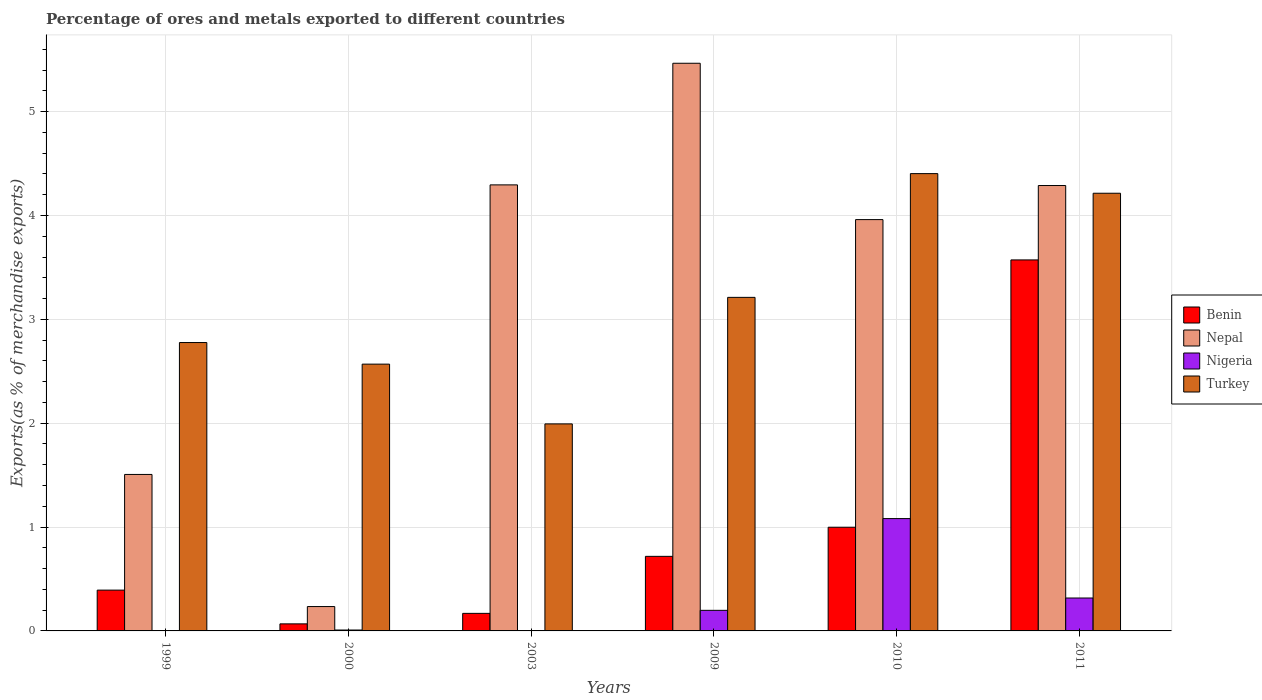How many groups of bars are there?
Keep it short and to the point. 6. How many bars are there on the 5th tick from the left?
Offer a terse response. 4. How many bars are there on the 1st tick from the right?
Ensure brevity in your answer.  4. What is the label of the 6th group of bars from the left?
Ensure brevity in your answer.  2011. In how many cases, is the number of bars for a given year not equal to the number of legend labels?
Keep it short and to the point. 0. What is the percentage of exports to different countries in Benin in 2000?
Offer a terse response. 0.07. Across all years, what is the maximum percentage of exports to different countries in Nepal?
Offer a very short reply. 5.47. Across all years, what is the minimum percentage of exports to different countries in Turkey?
Your response must be concise. 1.99. In which year was the percentage of exports to different countries in Nepal maximum?
Provide a succinct answer. 2009. In which year was the percentage of exports to different countries in Benin minimum?
Keep it short and to the point. 2000. What is the total percentage of exports to different countries in Benin in the graph?
Your response must be concise. 5.92. What is the difference between the percentage of exports to different countries in Turkey in 2009 and that in 2011?
Provide a succinct answer. -1. What is the difference between the percentage of exports to different countries in Nigeria in 2009 and the percentage of exports to different countries in Benin in 1999?
Offer a terse response. -0.19. What is the average percentage of exports to different countries in Nepal per year?
Ensure brevity in your answer.  3.29. In the year 2003, what is the difference between the percentage of exports to different countries in Nigeria and percentage of exports to different countries in Benin?
Your answer should be compact. -0.17. In how many years, is the percentage of exports to different countries in Benin greater than 3.8 %?
Give a very brief answer. 0. What is the ratio of the percentage of exports to different countries in Benin in 2000 to that in 2011?
Provide a short and direct response. 0.02. Is the percentage of exports to different countries in Benin in 2009 less than that in 2011?
Offer a very short reply. Yes. What is the difference between the highest and the second highest percentage of exports to different countries in Nigeria?
Provide a succinct answer. 0.76. What is the difference between the highest and the lowest percentage of exports to different countries in Nepal?
Offer a very short reply. 5.23. In how many years, is the percentage of exports to different countries in Nepal greater than the average percentage of exports to different countries in Nepal taken over all years?
Make the answer very short. 4. Is the sum of the percentage of exports to different countries in Nepal in 2003 and 2011 greater than the maximum percentage of exports to different countries in Turkey across all years?
Give a very brief answer. Yes. Is it the case that in every year, the sum of the percentage of exports to different countries in Nepal and percentage of exports to different countries in Nigeria is greater than the sum of percentage of exports to different countries in Turkey and percentage of exports to different countries in Benin?
Offer a very short reply. No. Is it the case that in every year, the sum of the percentage of exports to different countries in Turkey and percentage of exports to different countries in Nepal is greater than the percentage of exports to different countries in Nigeria?
Give a very brief answer. Yes. How many bars are there?
Your answer should be compact. 24. How many years are there in the graph?
Provide a short and direct response. 6. Are the values on the major ticks of Y-axis written in scientific E-notation?
Offer a very short reply. No. Where does the legend appear in the graph?
Keep it short and to the point. Center right. How many legend labels are there?
Offer a very short reply. 4. How are the legend labels stacked?
Offer a terse response. Vertical. What is the title of the graph?
Provide a short and direct response. Percentage of ores and metals exported to different countries. Does "Croatia" appear as one of the legend labels in the graph?
Offer a terse response. No. What is the label or title of the Y-axis?
Give a very brief answer. Exports(as % of merchandise exports). What is the Exports(as % of merchandise exports) of Benin in 1999?
Your answer should be compact. 0.39. What is the Exports(as % of merchandise exports) of Nepal in 1999?
Give a very brief answer. 1.51. What is the Exports(as % of merchandise exports) of Nigeria in 1999?
Your answer should be very brief. 0. What is the Exports(as % of merchandise exports) in Turkey in 1999?
Your response must be concise. 2.78. What is the Exports(as % of merchandise exports) in Benin in 2000?
Make the answer very short. 0.07. What is the Exports(as % of merchandise exports) in Nepal in 2000?
Your answer should be compact. 0.23. What is the Exports(as % of merchandise exports) in Nigeria in 2000?
Provide a short and direct response. 0.01. What is the Exports(as % of merchandise exports) in Turkey in 2000?
Make the answer very short. 2.57. What is the Exports(as % of merchandise exports) of Benin in 2003?
Provide a succinct answer. 0.17. What is the Exports(as % of merchandise exports) of Nepal in 2003?
Your answer should be compact. 4.29. What is the Exports(as % of merchandise exports) of Nigeria in 2003?
Your response must be concise. 0. What is the Exports(as % of merchandise exports) in Turkey in 2003?
Give a very brief answer. 1.99. What is the Exports(as % of merchandise exports) in Benin in 2009?
Give a very brief answer. 0.72. What is the Exports(as % of merchandise exports) of Nepal in 2009?
Your response must be concise. 5.47. What is the Exports(as % of merchandise exports) of Nigeria in 2009?
Your response must be concise. 0.2. What is the Exports(as % of merchandise exports) of Turkey in 2009?
Your answer should be very brief. 3.21. What is the Exports(as % of merchandise exports) of Benin in 2010?
Give a very brief answer. 1. What is the Exports(as % of merchandise exports) in Nepal in 2010?
Your answer should be compact. 3.96. What is the Exports(as % of merchandise exports) in Nigeria in 2010?
Your response must be concise. 1.08. What is the Exports(as % of merchandise exports) of Turkey in 2010?
Offer a terse response. 4.4. What is the Exports(as % of merchandise exports) in Benin in 2011?
Provide a short and direct response. 3.57. What is the Exports(as % of merchandise exports) of Nepal in 2011?
Your response must be concise. 4.29. What is the Exports(as % of merchandise exports) of Nigeria in 2011?
Ensure brevity in your answer.  0.32. What is the Exports(as % of merchandise exports) in Turkey in 2011?
Offer a very short reply. 4.21. Across all years, what is the maximum Exports(as % of merchandise exports) in Benin?
Keep it short and to the point. 3.57. Across all years, what is the maximum Exports(as % of merchandise exports) of Nepal?
Your answer should be compact. 5.47. Across all years, what is the maximum Exports(as % of merchandise exports) of Nigeria?
Give a very brief answer. 1.08. Across all years, what is the maximum Exports(as % of merchandise exports) in Turkey?
Provide a short and direct response. 4.4. Across all years, what is the minimum Exports(as % of merchandise exports) in Benin?
Your answer should be compact. 0.07. Across all years, what is the minimum Exports(as % of merchandise exports) in Nepal?
Your answer should be compact. 0.23. Across all years, what is the minimum Exports(as % of merchandise exports) of Nigeria?
Provide a short and direct response. 0. Across all years, what is the minimum Exports(as % of merchandise exports) of Turkey?
Offer a very short reply. 1.99. What is the total Exports(as % of merchandise exports) of Benin in the graph?
Ensure brevity in your answer.  5.92. What is the total Exports(as % of merchandise exports) of Nepal in the graph?
Ensure brevity in your answer.  19.75. What is the total Exports(as % of merchandise exports) of Nigeria in the graph?
Your response must be concise. 1.61. What is the total Exports(as % of merchandise exports) in Turkey in the graph?
Give a very brief answer. 19.17. What is the difference between the Exports(as % of merchandise exports) in Benin in 1999 and that in 2000?
Your response must be concise. 0.32. What is the difference between the Exports(as % of merchandise exports) in Nepal in 1999 and that in 2000?
Your answer should be compact. 1.27. What is the difference between the Exports(as % of merchandise exports) of Nigeria in 1999 and that in 2000?
Offer a very short reply. -0.01. What is the difference between the Exports(as % of merchandise exports) of Turkey in 1999 and that in 2000?
Your answer should be compact. 0.21. What is the difference between the Exports(as % of merchandise exports) of Benin in 1999 and that in 2003?
Make the answer very short. 0.22. What is the difference between the Exports(as % of merchandise exports) in Nepal in 1999 and that in 2003?
Offer a very short reply. -2.79. What is the difference between the Exports(as % of merchandise exports) of Nigeria in 1999 and that in 2003?
Provide a short and direct response. -0. What is the difference between the Exports(as % of merchandise exports) in Turkey in 1999 and that in 2003?
Provide a short and direct response. 0.78. What is the difference between the Exports(as % of merchandise exports) in Benin in 1999 and that in 2009?
Keep it short and to the point. -0.33. What is the difference between the Exports(as % of merchandise exports) in Nepal in 1999 and that in 2009?
Your answer should be compact. -3.96. What is the difference between the Exports(as % of merchandise exports) in Nigeria in 1999 and that in 2009?
Your response must be concise. -0.2. What is the difference between the Exports(as % of merchandise exports) of Turkey in 1999 and that in 2009?
Ensure brevity in your answer.  -0.43. What is the difference between the Exports(as % of merchandise exports) in Benin in 1999 and that in 2010?
Offer a terse response. -0.61. What is the difference between the Exports(as % of merchandise exports) in Nepal in 1999 and that in 2010?
Your answer should be compact. -2.45. What is the difference between the Exports(as % of merchandise exports) in Nigeria in 1999 and that in 2010?
Your answer should be very brief. -1.08. What is the difference between the Exports(as % of merchandise exports) in Turkey in 1999 and that in 2010?
Ensure brevity in your answer.  -1.63. What is the difference between the Exports(as % of merchandise exports) of Benin in 1999 and that in 2011?
Make the answer very short. -3.18. What is the difference between the Exports(as % of merchandise exports) in Nepal in 1999 and that in 2011?
Your response must be concise. -2.78. What is the difference between the Exports(as % of merchandise exports) of Nigeria in 1999 and that in 2011?
Provide a short and direct response. -0.31. What is the difference between the Exports(as % of merchandise exports) in Turkey in 1999 and that in 2011?
Ensure brevity in your answer.  -1.44. What is the difference between the Exports(as % of merchandise exports) in Benin in 2000 and that in 2003?
Offer a very short reply. -0.1. What is the difference between the Exports(as % of merchandise exports) of Nepal in 2000 and that in 2003?
Keep it short and to the point. -4.06. What is the difference between the Exports(as % of merchandise exports) in Nigeria in 2000 and that in 2003?
Your answer should be compact. 0.01. What is the difference between the Exports(as % of merchandise exports) of Turkey in 2000 and that in 2003?
Give a very brief answer. 0.58. What is the difference between the Exports(as % of merchandise exports) in Benin in 2000 and that in 2009?
Offer a very short reply. -0.65. What is the difference between the Exports(as % of merchandise exports) of Nepal in 2000 and that in 2009?
Your response must be concise. -5.23. What is the difference between the Exports(as % of merchandise exports) in Nigeria in 2000 and that in 2009?
Your response must be concise. -0.19. What is the difference between the Exports(as % of merchandise exports) of Turkey in 2000 and that in 2009?
Ensure brevity in your answer.  -0.64. What is the difference between the Exports(as % of merchandise exports) in Benin in 2000 and that in 2010?
Ensure brevity in your answer.  -0.93. What is the difference between the Exports(as % of merchandise exports) in Nepal in 2000 and that in 2010?
Provide a succinct answer. -3.73. What is the difference between the Exports(as % of merchandise exports) of Nigeria in 2000 and that in 2010?
Ensure brevity in your answer.  -1.07. What is the difference between the Exports(as % of merchandise exports) of Turkey in 2000 and that in 2010?
Give a very brief answer. -1.83. What is the difference between the Exports(as % of merchandise exports) in Benin in 2000 and that in 2011?
Offer a terse response. -3.5. What is the difference between the Exports(as % of merchandise exports) of Nepal in 2000 and that in 2011?
Your answer should be compact. -4.05. What is the difference between the Exports(as % of merchandise exports) of Nigeria in 2000 and that in 2011?
Offer a terse response. -0.31. What is the difference between the Exports(as % of merchandise exports) of Turkey in 2000 and that in 2011?
Your response must be concise. -1.65. What is the difference between the Exports(as % of merchandise exports) of Benin in 2003 and that in 2009?
Keep it short and to the point. -0.55. What is the difference between the Exports(as % of merchandise exports) of Nepal in 2003 and that in 2009?
Provide a succinct answer. -1.17. What is the difference between the Exports(as % of merchandise exports) of Nigeria in 2003 and that in 2009?
Keep it short and to the point. -0.2. What is the difference between the Exports(as % of merchandise exports) of Turkey in 2003 and that in 2009?
Your answer should be very brief. -1.22. What is the difference between the Exports(as % of merchandise exports) in Benin in 2003 and that in 2010?
Make the answer very short. -0.83. What is the difference between the Exports(as % of merchandise exports) of Nepal in 2003 and that in 2010?
Offer a very short reply. 0.33. What is the difference between the Exports(as % of merchandise exports) of Nigeria in 2003 and that in 2010?
Provide a succinct answer. -1.08. What is the difference between the Exports(as % of merchandise exports) of Turkey in 2003 and that in 2010?
Offer a very short reply. -2.41. What is the difference between the Exports(as % of merchandise exports) in Benin in 2003 and that in 2011?
Give a very brief answer. -3.4. What is the difference between the Exports(as % of merchandise exports) of Nepal in 2003 and that in 2011?
Keep it short and to the point. 0.01. What is the difference between the Exports(as % of merchandise exports) of Nigeria in 2003 and that in 2011?
Offer a very short reply. -0.31. What is the difference between the Exports(as % of merchandise exports) in Turkey in 2003 and that in 2011?
Your answer should be very brief. -2.22. What is the difference between the Exports(as % of merchandise exports) of Benin in 2009 and that in 2010?
Make the answer very short. -0.28. What is the difference between the Exports(as % of merchandise exports) in Nepal in 2009 and that in 2010?
Your response must be concise. 1.51. What is the difference between the Exports(as % of merchandise exports) in Nigeria in 2009 and that in 2010?
Provide a short and direct response. -0.88. What is the difference between the Exports(as % of merchandise exports) in Turkey in 2009 and that in 2010?
Your answer should be very brief. -1.19. What is the difference between the Exports(as % of merchandise exports) in Benin in 2009 and that in 2011?
Provide a succinct answer. -2.85. What is the difference between the Exports(as % of merchandise exports) of Nepal in 2009 and that in 2011?
Your answer should be compact. 1.18. What is the difference between the Exports(as % of merchandise exports) of Nigeria in 2009 and that in 2011?
Ensure brevity in your answer.  -0.12. What is the difference between the Exports(as % of merchandise exports) in Turkey in 2009 and that in 2011?
Provide a short and direct response. -1. What is the difference between the Exports(as % of merchandise exports) in Benin in 2010 and that in 2011?
Ensure brevity in your answer.  -2.57. What is the difference between the Exports(as % of merchandise exports) of Nepal in 2010 and that in 2011?
Give a very brief answer. -0.33. What is the difference between the Exports(as % of merchandise exports) of Nigeria in 2010 and that in 2011?
Make the answer very short. 0.76. What is the difference between the Exports(as % of merchandise exports) of Turkey in 2010 and that in 2011?
Give a very brief answer. 0.19. What is the difference between the Exports(as % of merchandise exports) of Benin in 1999 and the Exports(as % of merchandise exports) of Nepal in 2000?
Give a very brief answer. 0.16. What is the difference between the Exports(as % of merchandise exports) in Benin in 1999 and the Exports(as % of merchandise exports) in Nigeria in 2000?
Your response must be concise. 0.38. What is the difference between the Exports(as % of merchandise exports) of Benin in 1999 and the Exports(as % of merchandise exports) of Turkey in 2000?
Keep it short and to the point. -2.18. What is the difference between the Exports(as % of merchandise exports) of Nepal in 1999 and the Exports(as % of merchandise exports) of Nigeria in 2000?
Offer a terse response. 1.5. What is the difference between the Exports(as % of merchandise exports) in Nepal in 1999 and the Exports(as % of merchandise exports) in Turkey in 2000?
Provide a short and direct response. -1.06. What is the difference between the Exports(as % of merchandise exports) in Nigeria in 1999 and the Exports(as % of merchandise exports) in Turkey in 2000?
Give a very brief answer. -2.57. What is the difference between the Exports(as % of merchandise exports) of Benin in 1999 and the Exports(as % of merchandise exports) of Nepal in 2003?
Give a very brief answer. -3.9. What is the difference between the Exports(as % of merchandise exports) of Benin in 1999 and the Exports(as % of merchandise exports) of Nigeria in 2003?
Keep it short and to the point. 0.39. What is the difference between the Exports(as % of merchandise exports) in Benin in 1999 and the Exports(as % of merchandise exports) in Turkey in 2003?
Provide a succinct answer. -1.6. What is the difference between the Exports(as % of merchandise exports) in Nepal in 1999 and the Exports(as % of merchandise exports) in Nigeria in 2003?
Your answer should be compact. 1.5. What is the difference between the Exports(as % of merchandise exports) in Nepal in 1999 and the Exports(as % of merchandise exports) in Turkey in 2003?
Your answer should be compact. -0.49. What is the difference between the Exports(as % of merchandise exports) in Nigeria in 1999 and the Exports(as % of merchandise exports) in Turkey in 2003?
Provide a succinct answer. -1.99. What is the difference between the Exports(as % of merchandise exports) in Benin in 1999 and the Exports(as % of merchandise exports) in Nepal in 2009?
Your answer should be very brief. -5.07. What is the difference between the Exports(as % of merchandise exports) in Benin in 1999 and the Exports(as % of merchandise exports) in Nigeria in 2009?
Provide a succinct answer. 0.19. What is the difference between the Exports(as % of merchandise exports) of Benin in 1999 and the Exports(as % of merchandise exports) of Turkey in 2009?
Provide a succinct answer. -2.82. What is the difference between the Exports(as % of merchandise exports) of Nepal in 1999 and the Exports(as % of merchandise exports) of Nigeria in 2009?
Make the answer very short. 1.31. What is the difference between the Exports(as % of merchandise exports) in Nepal in 1999 and the Exports(as % of merchandise exports) in Turkey in 2009?
Give a very brief answer. -1.7. What is the difference between the Exports(as % of merchandise exports) of Nigeria in 1999 and the Exports(as % of merchandise exports) of Turkey in 2009?
Your response must be concise. -3.21. What is the difference between the Exports(as % of merchandise exports) in Benin in 1999 and the Exports(as % of merchandise exports) in Nepal in 2010?
Give a very brief answer. -3.57. What is the difference between the Exports(as % of merchandise exports) of Benin in 1999 and the Exports(as % of merchandise exports) of Nigeria in 2010?
Your response must be concise. -0.69. What is the difference between the Exports(as % of merchandise exports) in Benin in 1999 and the Exports(as % of merchandise exports) in Turkey in 2010?
Offer a terse response. -4.01. What is the difference between the Exports(as % of merchandise exports) of Nepal in 1999 and the Exports(as % of merchandise exports) of Nigeria in 2010?
Give a very brief answer. 0.42. What is the difference between the Exports(as % of merchandise exports) in Nepal in 1999 and the Exports(as % of merchandise exports) in Turkey in 2010?
Keep it short and to the point. -2.9. What is the difference between the Exports(as % of merchandise exports) of Nigeria in 1999 and the Exports(as % of merchandise exports) of Turkey in 2010?
Offer a very short reply. -4.4. What is the difference between the Exports(as % of merchandise exports) of Benin in 1999 and the Exports(as % of merchandise exports) of Nepal in 2011?
Provide a succinct answer. -3.9. What is the difference between the Exports(as % of merchandise exports) in Benin in 1999 and the Exports(as % of merchandise exports) in Nigeria in 2011?
Your response must be concise. 0.08. What is the difference between the Exports(as % of merchandise exports) of Benin in 1999 and the Exports(as % of merchandise exports) of Turkey in 2011?
Ensure brevity in your answer.  -3.82. What is the difference between the Exports(as % of merchandise exports) in Nepal in 1999 and the Exports(as % of merchandise exports) in Nigeria in 2011?
Make the answer very short. 1.19. What is the difference between the Exports(as % of merchandise exports) in Nepal in 1999 and the Exports(as % of merchandise exports) in Turkey in 2011?
Offer a very short reply. -2.71. What is the difference between the Exports(as % of merchandise exports) of Nigeria in 1999 and the Exports(as % of merchandise exports) of Turkey in 2011?
Offer a very short reply. -4.21. What is the difference between the Exports(as % of merchandise exports) in Benin in 2000 and the Exports(as % of merchandise exports) in Nepal in 2003?
Provide a short and direct response. -4.23. What is the difference between the Exports(as % of merchandise exports) in Benin in 2000 and the Exports(as % of merchandise exports) in Nigeria in 2003?
Your answer should be very brief. 0.07. What is the difference between the Exports(as % of merchandise exports) of Benin in 2000 and the Exports(as % of merchandise exports) of Turkey in 2003?
Offer a very short reply. -1.93. What is the difference between the Exports(as % of merchandise exports) in Nepal in 2000 and the Exports(as % of merchandise exports) in Nigeria in 2003?
Offer a terse response. 0.23. What is the difference between the Exports(as % of merchandise exports) in Nepal in 2000 and the Exports(as % of merchandise exports) in Turkey in 2003?
Your answer should be very brief. -1.76. What is the difference between the Exports(as % of merchandise exports) in Nigeria in 2000 and the Exports(as % of merchandise exports) in Turkey in 2003?
Keep it short and to the point. -1.98. What is the difference between the Exports(as % of merchandise exports) in Benin in 2000 and the Exports(as % of merchandise exports) in Nepal in 2009?
Make the answer very short. -5.4. What is the difference between the Exports(as % of merchandise exports) in Benin in 2000 and the Exports(as % of merchandise exports) in Nigeria in 2009?
Ensure brevity in your answer.  -0.13. What is the difference between the Exports(as % of merchandise exports) of Benin in 2000 and the Exports(as % of merchandise exports) of Turkey in 2009?
Your answer should be very brief. -3.14. What is the difference between the Exports(as % of merchandise exports) of Nepal in 2000 and the Exports(as % of merchandise exports) of Nigeria in 2009?
Offer a very short reply. 0.04. What is the difference between the Exports(as % of merchandise exports) in Nepal in 2000 and the Exports(as % of merchandise exports) in Turkey in 2009?
Ensure brevity in your answer.  -2.98. What is the difference between the Exports(as % of merchandise exports) in Nigeria in 2000 and the Exports(as % of merchandise exports) in Turkey in 2009?
Give a very brief answer. -3.2. What is the difference between the Exports(as % of merchandise exports) of Benin in 2000 and the Exports(as % of merchandise exports) of Nepal in 2010?
Make the answer very short. -3.89. What is the difference between the Exports(as % of merchandise exports) in Benin in 2000 and the Exports(as % of merchandise exports) in Nigeria in 2010?
Your answer should be very brief. -1.01. What is the difference between the Exports(as % of merchandise exports) in Benin in 2000 and the Exports(as % of merchandise exports) in Turkey in 2010?
Your answer should be compact. -4.33. What is the difference between the Exports(as % of merchandise exports) of Nepal in 2000 and the Exports(as % of merchandise exports) of Nigeria in 2010?
Your answer should be very brief. -0.85. What is the difference between the Exports(as % of merchandise exports) of Nepal in 2000 and the Exports(as % of merchandise exports) of Turkey in 2010?
Offer a very short reply. -4.17. What is the difference between the Exports(as % of merchandise exports) in Nigeria in 2000 and the Exports(as % of merchandise exports) in Turkey in 2010?
Offer a terse response. -4.39. What is the difference between the Exports(as % of merchandise exports) of Benin in 2000 and the Exports(as % of merchandise exports) of Nepal in 2011?
Your response must be concise. -4.22. What is the difference between the Exports(as % of merchandise exports) of Benin in 2000 and the Exports(as % of merchandise exports) of Nigeria in 2011?
Keep it short and to the point. -0.25. What is the difference between the Exports(as % of merchandise exports) of Benin in 2000 and the Exports(as % of merchandise exports) of Turkey in 2011?
Make the answer very short. -4.15. What is the difference between the Exports(as % of merchandise exports) in Nepal in 2000 and the Exports(as % of merchandise exports) in Nigeria in 2011?
Offer a very short reply. -0.08. What is the difference between the Exports(as % of merchandise exports) in Nepal in 2000 and the Exports(as % of merchandise exports) in Turkey in 2011?
Provide a short and direct response. -3.98. What is the difference between the Exports(as % of merchandise exports) in Nigeria in 2000 and the Exports(as % of merchandise exports) in Turkey in 2011?
Give a very brief answer. -4.21. What is the difference between the Exports(as % of merchandise exports) in Benin in 2003 and the Exports(as % of merchandise exports) in Nepal in 2009?
Your response must be concise. -5.3. What is the difference between the Exports(as % of merchandise exports) of Benin in 2003 and the Exports(as % of merchandise exports) of Nigeria in 2009?
Provide a short and direct response. -0.03. What is the difference between the Exports(as % of merchandise exports) of Benin in 2003 and the Exports(as % of merchandise exports) of Turkey in 2009?
Keep it short and to the point. -3.04. What is the difference between the Exports(as % of merchandise exports) of Nepal in 2003 and the Exports(as % of merchandise exports) of Nigeria in 2009?
Give a very brief answer. 4.1. What is the difference between the Exports(as % of merchandise exports) of Nepal in 2003 and the Exports(as % of merchandise exports) of Turkey in 2009?
Provide a succinct answer. 1.08. What is the difference between the Exports(as % of merchandise exports) in Nigeria in 2003 and the Exports(as % of merchandise exports) in Turkey in 2009?
Keep it short and to the point. -3.21. What is the difference between the Exports(as % of merchandise exports) of Benin in 2003 and the Exports(as % of merchandise exports) of Nepal in 2010?
Provide a succinct answer. -3.79. What is the difference between the Exports(as % of merchandise exports) in Benin in 2003 and the Exports(as % of merchandise exports) in Nigeria in 2010?
Your response must be concise. -0.91. What is the difference between the Exports(as % of merchandise exports) in Benin in 2003 and the Exports(as % of merchandise exports) in Turkey in 2010?
Provide a short and direct response. -4.23. What is the difference between the Exports(as % of merchandise exports) of Nepal in 2003 and the Exports(as % of merchandise exports) of Nigeria in 2010?
Ensure brevity in your answer.  3.21. What is the difference between the Exports(as % of merchandise exports) of Nepal in 2003 and the Exports(as % of merchandise exports) of Turkey in 2010?
Ensure brevity in your answer.  -0.11. What is the difference between the Exports(as % of merchandise exports) of Benin in 2003 and the Exports(as % of merchandise exports) of Nepal in 2011?
Your answer should be very brief. -4.12. What is the difference between the Exports(as % of merchandise exports) in Benin in 2003 and the Exports(as % of merchandise exports) in Nigeria in 2011?
Ensure brevity in your answer.  -0.15. What is the difference between the Exports(as % of merchandise exports) of Benin in 2003 and the Exports(as % of merchandise exports) of Turkey in 2011?
Offer a terse response. -4.04. What is the difference between the Exports(as % of merchandise exports) in Nepal in 2003 and the Exports(as % of merchandise exports) in Nigeria in 2011?
Make the answer very short. 3.98. What is the difference between the Exports(as % of merchandise exports) in Nepal in 2003 and the Exports(as % of merchandise exports) in Turkey in 2011?
Offer a very short reply. 0.08. What is the difference between the Exports(as % of merchandise exports) of Nigeria in 2003 and the Exports(as % of merchandise exports) of Turkey in 2011?
Provide a short and direct response. -4.21. What is the difference between the Exports(as % of merchandise exports) of Benin in 2009 and the Exports(as % of merchandise exports) of Nepal in 2010?
Offer a very short reply. -3.24. What is the difference between the Exports(as % of merchandise exports) in Benin in 2009 and the Exports(as % of merchandise exports) in Nigeria in 2010?
Offer a terse response. -0.36. What is the difference between the Exports(as % of merchandise exports) in Benin in 2009 and the Exports(as % of merchandise exports) in Turkey in 2010?
Your answer should be compact. -3.68. What is the difference between the Exports(as % of merchandise exports) in Nepal in 2009 and the Exports(as % of merchandise exports) in Nigeria in 2010?
Offer a very short reply. 4.38. What is the difference between the Exports(as % of merchandise exports) of Nigeria in 2009 and the Exports(as % of merchandise exports) of Turkey in 2010?
Offer a very short reply. -4.2. What is the difference between the Exports(as % of merchandise exports) in Benin in 2009 and the Exports(as % of merchandise exports) in Nepal in 2011?
Give a very brief answer. -3.57. What is the difference between the Exports(as % of merchandise exports) in Benin in 2009 and the Exports(as % of merchandise exports) in Nigeria in 2011?
Your answer should be compact. 0.4. What is the difference between the Exports(as % of merchandise exports) in Benin in 2009 and the Exports(as % of merchandise exports) in Turkey in 2011?
Offer a terse response. -3.5. What is the difference between the Exports(as % of merchandise exports) in Nepal in 2009 and the Exports(as % of merchandise exports) in Nigeria in 2011?
Your answer should be compact. 5.15. What is the difference between the Exports(as % of merchandise exports) in Nepal in 2009 and the Exports(as % of merchandise exports) in Turkey in 2011?
Your answer should be very brief. 1.25. What is the difference between the Exports(as % of merchandise exports) of Nigeria in 2009 and the Exports(as % of merchandise exports) of Turkey in 2011?
Provide a short and direct response. -4.02. What is the difference between the Exports(as % of merchandise exports) in Benin in 2010 and the Exports(as % of merchandise exports) in Nepal in 2011?
Make the answer very short. -3.29. What is the difference between the Exports(as % of merchandise exports) of Benin in 2010 and the Exports(as % of merchandise exports) of Nigeria in 2011?
Your response must be concise. 0.68. What is the difference between the Exports(as % of merchandise exports) of Benin in 2010 and the Exports(as % of merchandise exports) of Turkey in 2011?
Your answer should be very brief. -3.22. What is the difference between the Exports(as % of merchandise exports) of Nepal in 2010 and the Exports(as % of merchandise exports) of Nigeria in 2011?
Your answer should be compact. 3.64. What is the difference between the Exports(as % of merchandise exports) of Nepal in 2010 and the Exports(as % of merchandise exports) of Turkey in 2011?
Offer a very short reply. -0.25. What is the difference between the Exports(as % of merchandise exports) of Nigeria in 2010 and the Exports(as % of merchandise exports) of Turkey in 2011?
Offer a terse response. -3.13. What is the average Exports(as % of merchandise exports) in Benin per year?
Provide a short and direct response. 0.99. What is the average Exports(as % of merchandise exports) in Nepal per year?
Ensure brevity in your answer.  3.29. What is the average Exports(as % of merchandise exports) in Nigeria per year?
Your answer should be compact. 0.27. What is the average Exports(as % of merchandise exports) in Turkey per year?
Provide a succinct answer. 3.19. In the year 1999, what is the difference between the Exports(as % of merchandise exports) of Benin and Exports(as % of merchandise exports) of Nepal?
Ensure brevity in your answer.  -1.11. In the year 1999, what is the difference between the Exports(as % of merchandise exports) of Benin and Exports(as % of merchandise exports) of Nigeria?
Provide a succinct answer. 0.39. In the year 1999, what is the difference between the Exports(as % of merchandise exports) in Benin and Exports(as % of merchandise exports) in Turkey?
Offer a terse response. -2.38. In the year 1999, what is the difference between the Exports(as % of merchandise exports) of Nepal and Exports(as % of merchandise exports) of Nigeria?
Offer a terse response. 1.5. In the year 1999, what is the difference between the Exports(as % of merchandise exports) in Nepal and Exports(as % of merchandise exports) in Turkey?
Your answer should be very brief. -1.27. In the year 1999, what is the difference between the Exports(as % of merchandise exports) of Nigeria and Exports(as % of merchandise exports) of Turkey?
Your answer should be compact. -2.77. In the year 2000, what is the difference between the Exports(as % of merchandise exports) in Benin and Exports(as % of merchandise exports) in Nepal?
Offer a terse response. -0.17. In the year 2000, what is the difference between the Exports(as % of merchandise exports) in Benin and Exports(as % of merchandise exports) in Nigeria?
Provide a succinct answer. 0.06. In the year 2000, what is the difference between the Exports(as % of merchandise exports) in Benin and Exports(as % of merchandise exports) in Turkey?
Your answer should be very brief. -2.5. In the year 2000, what is the difference between the Exports(as % of merchandise exports) in Nepal and Exports(as % of merchandise exports) in Nigeria?
Provide a succinct answer. 0.23. In the year 2000, what is the difference between the Exports(as % of merchandise exports) of Nepal and Exports(as % of merchandise exports) of Turkey?
Offer a very short reply. -2.33. In the year 2000, what is the difference between the Exports(as % of merchandise exports) of Nigeria and Exports(as % of merchandise exports) of Turkey?
Provide a succinct answer. -2.56. In the year 2003, what is the difference between the Exports(as % of merchandise exports) of Benin and Exports(as % of merchandise exports) of Nepal?
Keep it short and to the point. -4.13. In the year 2003, what is the difference between the Exports(as % of merchandise exports) in Benin and Exports(as % of merchandise exports) in Nigeria?
Offer a very short reply. 0.17. In the year 2003, what is the difference between the Exports(as % of merchandise exports) of Benin and Exports(as % of merchandise exports) of Turkey?
Make the answer very short. -1.82. In the year 2003, what is the difference between the Exports(as % of merchandise exports) of Nepal and Exports(as % of merchandise exports) of Nigeria?
Provide a short and direct response. 4.29. In the year 2003, what is the difference between the Exports(as % of merchandise exports) in Nepal and Exports(as % of merchandise exports) in Turkey?
Offer a terse response. 2.3. In the year 2003, what is the difference between the Exports(as % of merchandise exports) of Nigeria and Exports(as % of merchandise exports) of Turkey?
Provide a short and direct response. -1.99. In the year 2009, what is the difference between the Exports(as % of merchandise exports) in Benin and Exports(as % of merchandise exports) in Nepal?
Offer a terse response. -4.75. In the year 2009, what is the difference between the Exports(as % of merchandise exports) in Benin and Exports(as % of merchandise exports) in Nigeria?
Provide a succinct answer. 0.52. In the year 2009, what is the difference between the Exports(as % of merchandise exports) of Benin and Exports(as % of merchandise exports) of Turkey?
Ensure brevity in your answer.  -2.49. In the year 2009, what is the difference between the Exports(as % of merchandise exports) of Nepal and Exports(as % of merchandise exports) of Nigeria?
Your answer should be compact. 5.27. In the year 2009, what is the difference between the Exports(as % of merchandise exports) of Nepal and Exports(as % of merchandise exports) of Turkey?
Keep it short and to the point. 2.25. In the year 2009, what is the difference between the Exports(as % of merchandise exports) in Nigeria and Exports(as % of merchandise exports) in Turkey?
Ensure brevity in your answer.  -3.01. In the year 2010, what is the difference between the Exports(as % of merchandise exports) of Benin and Exports(as % of merchandise exports) of Nepal?
Give a very brief answer. -2.96. In the year 2010, what is the difference between the Exports(as % of merchandise exports) of Benin and Exports(as % of merchandise exports) of Nigeria?
Your answer should be very brief. -0.08. In the year 2010, what is the difference between the Exports(as % of merchandise exports) in Benin and Exports(as % of merchandise exports) in Turkey?
Your response must be concise. -3.4. In the year 2010, what is the difference between the Exports(as % of merchandise exports) of Nepal and Exports(as % of merchandise exports) of Nigeria?
Keep it short and to the point. 2.88. In the year 2010, what is the difference between the Exports(as % of merchandise exports) of Nepal and Exports(as % of merchandise exports) of Turkey?
Give a very brief answer. -0.44. In the year 2010, what is the difference between the Exports(as % of merchandise exports) of Nigeria and Exports(as % of merchandise exports) of Turkey?
Provide a succinct answer. -3.32. In the year 2011, what is the difference between the Exports(as % of merchandise exports) in Benin and Exports(as % of merchandise exports) in Nepal?
Keep it short and to the point. -0.72. In the year 2011, what is the difference between the Exports(as % of merchandise exports) of Benin and Exports(as % of merchandise exports) of Nigeria?
Provide a short and direct response. 3.25. In the year 2011, what is the difference between the Exports(as % of merchandise exports) in Benin and Exports(as % of merchandise exports) in Turkey?
Provide a succinct answer. -0.64. In the year 2011, what is the difference between the Exports(as % of merchandise exports) of Nepal and Exports(as % of merchandise exports) of Nigeria?
Provide a succinct answer. 3.97. In the year 2011, what is the difference between the Exports(as % of merchandise exports) in Nepal and Exports(as % of merchandise exports) in Turkey?
Make the answer very short. 0.07. In the year 2011, what is the difference between the Exports(as % of merchandise exports) of Nigeria and Exports(as % of merchandise exports) of Turkey?
Keep it short and to the point. -3.9. What is the ratio of the Exports(as % of merchandise exports) of Benin in 1999 to that in 2000?
Provide a short and direct response. 5.78. What is the ratio of the Exports(as % of merchandise exports) in Nepal in 1999 to that in 2000?
Provide a succinct answer. 6.42. What is the ratio of the Exports(as % of merchandise exports) in Nigeria in 1999 to that in 2000?
Make the answer very short. 0.31. What is the ratio of the Exports(as % of merchandise exports) in Turkey in 1999 to that in 2000?
Ensure brevity in your answer.  1.08. What is the ratio of the Exports(as % of merchandise exports) in Benin in 1999 to that in 2003?
Your answer should be very brief. 2.33. What is the ratio of the Exports(as % of merchandise exports) in Nepal in 1999 to that in 2003?
Offer a very short reply. 0.35. What is the ratio of the Exports(as % of merchandise exports) of Nigeria in 1999 to that in 2003?
Your answer should be very brief. 0.94. What is the ratio of the Exports(as % of merchandise exports) in Turkey in 1999 to that in 2003?
Provide a succinct answer. 1.39. What is the ratio of the Exports(as % of merchandise exports) of Benin in 1999 to that in 2009?
Provide a short and direct response. 0.55. What is the ratio of the Exports(as % of merchandise exports) of Nepal in 1999 to that in 2009?
Provide a succinct answer. 0.28. What is the ratio of the Exports(as % of merchandise exports) of Nigeria in 1999 to that in 2009?
Keep it short and to the point. 0.01. What is the ratio of the Exports(as % of merchandise exports) of Turkey in 1999 to that in 2009?
Ensure brevity in your answer.  0.86. What is the ratio of the Exports(as % of merchandise exports) of Benin in 1999 to that in 2010?
Give a very brief answer. 0.39. What is the ratio of the Exports(as % of merchandise exports) in Nepal in 1999 to that in 2010?
Keep it short and to the point. 0.38. What is the ratio of the Exports(as % of merchandise exports) in Nigeria in 1999 to that in 2010?
Your answer should be very brief. 0. What is the ratio of the Exports(as % of merchandise exports) of Turkey in 1999 to that in 2010?
Keep it short and to the point. 0.63. What is the ratio of the Exports(as % of merchandise exports) of Benin in 1999 to that in 2011?
Make the answer very short. 0.11. What is the ratio of the Exports(as % of merchandise exports) in Nepal in 1999 to that in 2011?
Offer a very short reply. 0.35. What is the ratio of the Exports(as % of merchandise exports) in Nigeria in 1999 to that in 2011?
Keep it short and to the point. 0.01. What is the ratio of the Exports(as % of merchandise exports) of Turkey in 1999 to that in 2011?
Your answer should be very brief. 0.66. What is the ratio of the Exports(as % of merchandise exports) of Benin in 2000 to that in 2003?
Provide a short and direct response. 0.4. What is the ratio of the Exports(as % of merchandise exports) of Nepal in 2000 to that in 2003?
Offer a terse response. 0.05. What is the ratio of the Exports(as % of merchandise exports) in Nigeria in 2000 to that in 2003?
Offer a very short reply. 3.06. What is the ratio of the Exports(as % of merchandise exports) in Turkey in 2000 to that in 2003?
Offer a terse response. 1.29. What is the ratio of the Exports(as % of merchandise exports) of Benin in 2000 to that in 2009?
Give a very brief answer. 0.09. What is the ratio of the Exports(as % of merchandise exports) in Nepal in 2000 to that in 2009?
Ensure brevity in your answer.  0.04. What is the ratio of the Exports(as % of merchandise exports) of Nigeria in 2000 to that in 2009?
Offer a terse response. 0.04. What is the ratio of the Exports(as % of merchandise exports) of Turkey in 2000 to that in 2009?
Ensure brevity in your answer.  0.8. What is the ratio of the Exports(as % of merchandise exports) of Benin in 2000 to that in 2010?
Provide a short and direct response. 0.07. What is the ratio of the Exports(as % of merchandise exports) in Nepal in 2000 to that in 2010?
Offer a terse response. 0.06. What is the ratio of the Exports(as % of merchandise exports) in Nigeria in 2000 to that in 2010?
Provide a short and direct response. 0.01. What is the ratio of the Exports(as % of merchandise exports) in Turkey in 2000 to that in 2010?
Provide a short and direct response. 0.58. What is the ratio of the Exports(as % of merchandise exports) in Benin in 2000 to that in 2011?
Ensure brevity in your answer.  0.02. What is the ratio of the Exports(as % of merchandise exports) of Nepal in 2000 to that in 2011?
Your answer should be very brief. 0.05. What is the ratio of the Exports(as % of merchandise exports) of Nigeria in 2000 to that in 2011?
Your response must be concise. 0.03. What is the ratio of the Exports(as % of merchandise exports) in Turkey in 2000 to that in 2011?
Offer a very short reply. 0.61. What is the ratio of the Exports(as % of merchandise exports) of Benin in 2003 to that in 2009?
Your answer should be compact. 0.24. What is the ratio of the Exports(as % of merchandise exports) of Nepal in 2003 to that in 2009?
Offer a terse response. 0.79. What is the ratio of the Exports(as % of merchandise exports) in Nigeria in 2003 to that in 2009?
Ensure brevity in your answer.  0.01. What is the ratio of the Exports(as % of merchandise exports) in Turkey in 2003 to that in 2009?
Offer a terse response. 0.62. What is the ratio of the Exports(as % of merchandise exports) of Benin in 2003 to that in 2010?
Provide a succinct answer. 0.17. What is the ratio of the Exports(as % of merchandise exports) in Nepal in 2003 to that in 2010?
Provide a short and direct response. 1.08. What is the ratio of the Exports(as % of merchandise exports) of Nigeria in 2003 to that in 2010?
Offer a very short reply. 0. What is the ratio of the Exports(as % of merchandise exports) of Turkey in 2003 to that in 2010?
Your response must be concise. 0.45. What is the ratio of the Exports(as % of merchandise exports) in Benin in 2003 to that in 2011?
Make the answer very short. 0.05. What is the ratio of the Exports(as % of merchandise exports) in Nepal in 2003 to that in 2011?
Offer a terse response. 1. What is the ratio of the Exports(as % of merchandise exports) of Nigeria in 2003 to that in 2011?
Offer a very short reply. 0.01. What is the ratio of the Exports(as % of merchandise exports) of Turkey in 2003 to that in 2011?
Give a very brief answer. 0.47. What is the ratio of the Exports(as % of merchandise exports) of Benin in 2009 to that in 2010?
Keep it short and to the point. 0.72. What is the ratio of the Exports(as % of merchandise exports) of Nepal in 2009 to that in 2010?
Your response must be concise. 1.38. What is the ratio of the Exports(as % of merchandise exports) in Nigeria in 2009 to that in 2010?
Offer a very short reply. 0.18. What is the ratio of the Exports(as % of merchandise exports) of Turkey in 2009 to that in 2010?
Provide a short and direct response. 0.73. What is the ratio of the Exports(as % of merchandise exports) in Benin in 2009 to that in 2011?
Ensure brevity in your answer.  0.2. What is the ratio of the Exports(as % of merchandise exports) of Nepal in 2009 to that in 2011?
Give a very brief answer. 1.27. What is the ratio of the Exports(as % of merchandise exports) in Nigeria in 2009 to that in 2011?
Provide a succinct answer. 0.63. What is the ratio of the Exports(as % of merchandise exports) in Turkey in 2009 to that in 2011?
Make the answer very short. 0.76. What is the ratio of the Exports(as % of merchandise exports) of Benin in 2010 to that in 2011?
Your answer should be very brief. 0.28. What is the ratio of the Exports(as % of merchandise exports) in Nepal in 2010 to that in 2011?
Keep it short and to the point. 0.92. What is the ratio of the Exports(as % of merchandise exports) of Nigeria in 2010 to that in 2011?
Provide a short and direct response. 3.41. What is the ratio of the Exports(as % of merchandise exports) of Turkey in 2010 to that in 2011?
Provide a succinct answer. 1.04. What is the difference between the highest and the second highest Exports(as % of merchandise exports) in Benin?
Offer a very short reply. 2.57. What is the difference between the highest and the second highest Exports(as % of merchandise exports) of Nepal?
Provide a succinct answer. 1.17. What is the difference between the highest and the second highest Exports(as % of merchandise exports) of Nigeria?
Offer a terse response. 0.76. What is the difference between the highest and the second highest Exports(as % of merchandise exports) in Turkey?
Provide a short and direct response. 0.19. What is the difference between the highest and the lowest Exports(as % of merchandise exports) in Benin?
Make the answer very short. 3.5. What is the difference between the highest and the lowest Exports(as % of merchandise exports) of Nepal?
Your answer should be compact. 5.23. What is the difference between the highest and the lowest Exports(as % of merchandise exports) in Nigeria?
Make the answer very short. 1.08. What is the difference between the highest and the lowest Exports(as % of merchandise exports) in Turkey?
Your response must be concise. 2.41. 